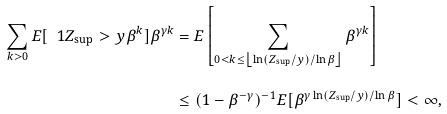<formula> <loc_0><loc_0><loc_500><loc_500>\sum _ { k > 0 } E [ \ 1 { Z _ { \text {sup} } > y \beta ^ { k } } ] \beta ^ { \gamma k } & = E \left [ \sum _ { 0 < k \leq \left \lfloor \ln ( Z _ { \text {sup} } / y ) / \ln \beta \right \rfloor } \beta ^ { \gamma k } \right ] \\ & \leq ( 1 - \beta ^ { - \gamma } ) ^ { - 1 } E [ \beta ^ { \gamma \ln ( Z _ { \text {sup} } / y ) / \ln \beta } ] < \infty ,</formula> 